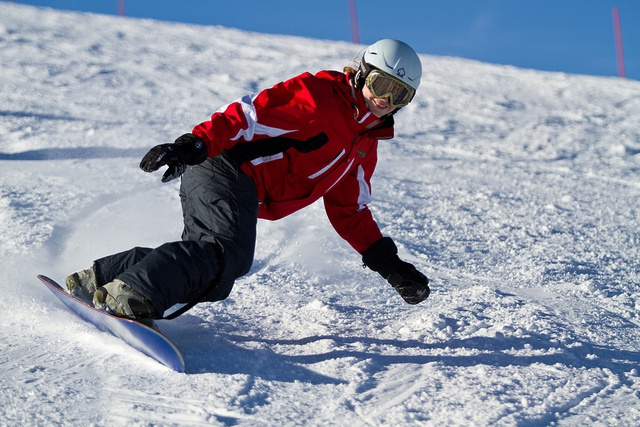Describe the objects in this image and their specific colors. I can see people in gray, black, maroon, and lightgray tones and snowboard in gray, blue, and darkgray tones in this image. 